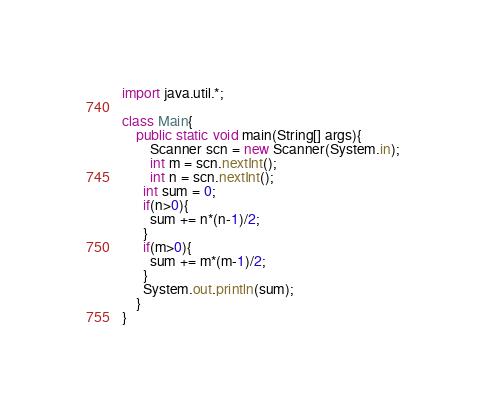<code> <loc_0><loc_0><loc_500><loc_500><_Java_>import java.util.*;

class Main{
	public static void main(String[] args){
		Scanner scn = new Scanner(System.in);
    	int m = scn.nextInt();
    	int n = scn.nextInt();
      int sum = 0;
      if(n>0){
        sum += n*(n-1)/2;
      }
      if(m>0){
        sum += m*(m-1)/2;
      }
      System.out.println(sum);
	}
}
</code> 